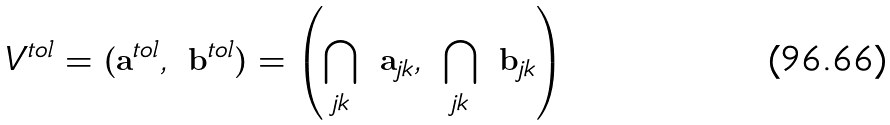<formula> <loc_0><loc_0><loc_500><loc_500>V ^ { t o l } = \left ( { \mathbf a } ^ { t o l } , \ { \mathbf b } ^ { t o l } \right ) = \left ( \bigcap _ { j k } \ { \mathbf a } _ { j k } , \ \bigcap _ { j k } \ { \mathbf b } _ { j k } \right )</formula> 